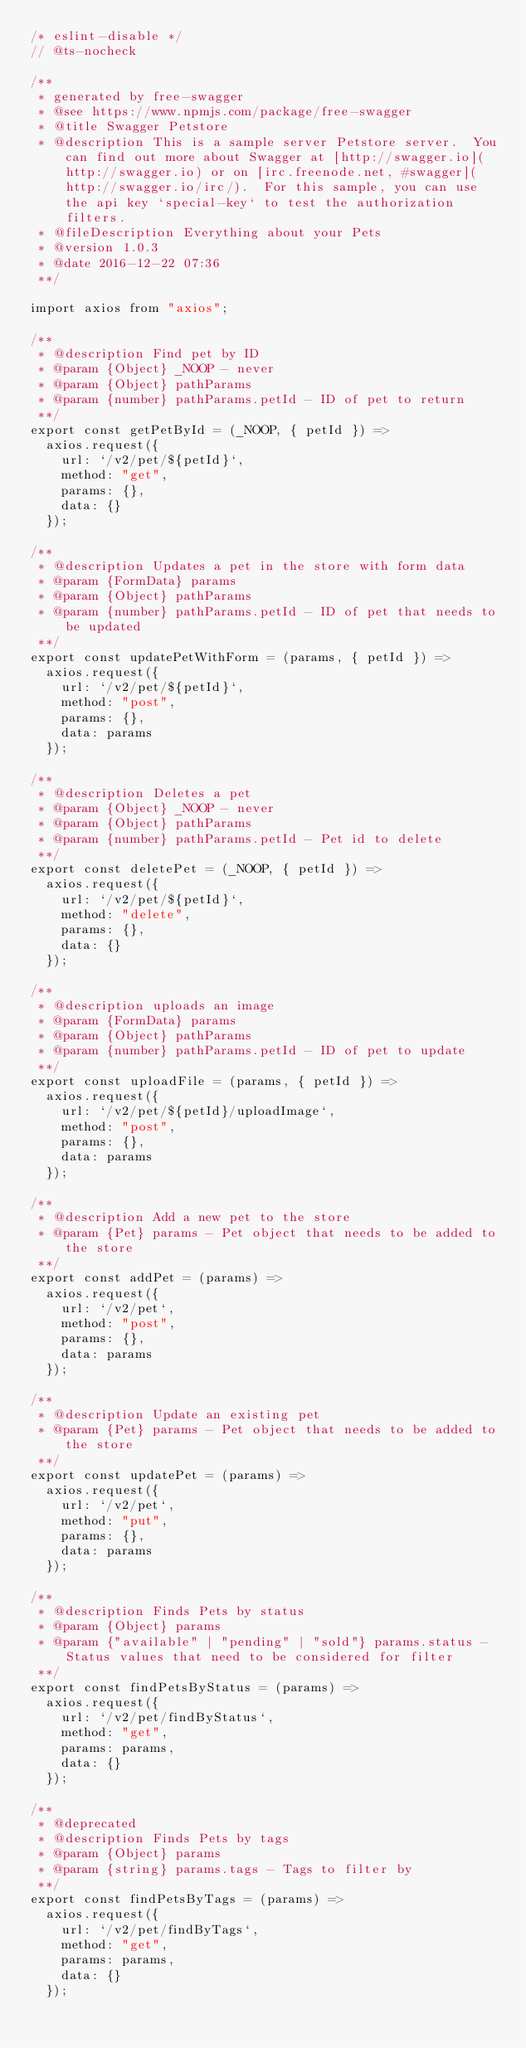<code> <loc_0><loc_0><loc_500><loc_500><_JavaScript_>/* eslint-disable */
// @ts-nocheck

/**
 * generated by free-swagger
 * @see https://www.npmjs.com/package/free-swagger
 * @title Swagger Petstore
 * @description This is a sample server Petstore server.  You can find out more about Swagger at [http://swagger.io](http://swagger.io) or on [irc.freenode.net, #swagger](http://swagger.io/irc/).  For this sample, you can use the api key `special-key` to test the authorization filters.
 * @fileDescription Everything about your Pets
 * @version 1.0.3
 * @date 2016-12-22 07:36
 **/

import axios from "axios";

/**
 * @description Find pet by ID
 * @param {Object} _NOOP - never
 * @param {Object} pathParams
 * @param {number} pathParams.petId - ID of pet to return
 **/
export const getPetById = (_NOOP, { petId }) =>
  axios.request({
    url: `/v2/pet/${petId}`,
    method: "get",
    params: {},
    data: {}
  });

/**
 * @description Updates a pet in the store with form data
 * @param {FormData} params
 * @param {Object} pathParams
 * @param {number} pathParams.petId - ID of pet that needs to be updated
 **/
export const updatePetWithForm = (params, { petId }) =>
  axios.request({
    url: `/v2/pet/${petId}`,
    method: "post",
    params: {},
    data: params
  });

/**
 * @description Deletes a pet
 * @param {Object} _NOOP - never
 * @param {Object} pathParams
 * @param {number} pathParams.petId - Pet id to delete
 **/
export const deletePet = (_NOOP, { petId }) =>
  axios.request({
    url: `/v2/pet/${petId}`,
    method: "delete",
    params: {},
    data: {}
  });

/**
 * @description uploads an image
 * @param {FormData} params
 * @param {Object} pathParams
 * @param {number} pathParams.petId - ID of pet to update
 **/
export const uploadFile = (params, { petId }) =>
  axios.request({
    url: `/v2/pet/${petId}/uploadImage`,
    method: "post",
    params: {},
    data: params
  });

/**
 * @description Add a new pet to the store
 * @param {Pet} params - Pet object that needs to be added to the store
 **/
export const addPet = (params) =>
  axios.request({
    url: `/v2/pet`,
    method: "post",
    params: {},
    data: params
  });

/**
 * @description Update an existing pet
 * @param {Pet} params - Pet object that needs to be added to the store
 **/
export const updatePet = (params) =>
  axios.request({
    url: `/v2/pet`,
    method: "put",
    params: {},
    data: params
  });

/**
 * @description Finds Pets by status
 * @param {Object} params
 * @param {"available" | "pending" | "sold"} params.status - Status values that need to be considered for filter
 **/
export const findPetsByStatus = (params) =>
  axios.request({
    url: `/v2/pet/findByStatus`,
    method: "get",
    params: params,
    data: {}
  });

/**
 * @deprecated
 * @description Finds Pets by tags
 * @param {Object} params
 * @param {string} params.tags - Tags to filter by
 **/
export const findPetsByTags = (params) =>
  axios.request({
    url: `/v2/pet/findByTags`,
    method: "get",
    params: params,
    data: {}
  });
</code> 